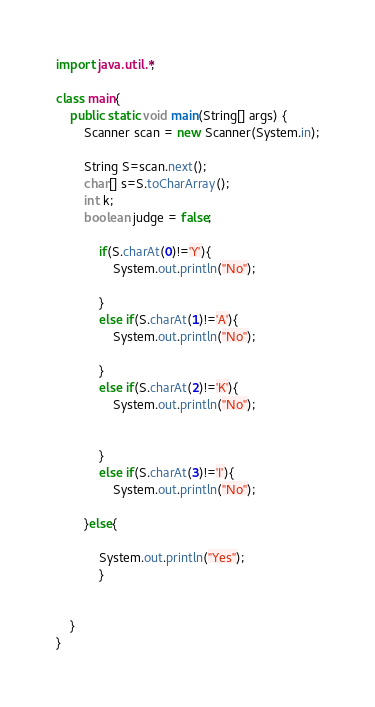<code> <loc_0><loc_0><loc_500><loc_500><_Java_>import java.util.*;

class main{
    public static void main(String[] args) {
        Scanner scan = new Scanner(System.in);

        String S=scan.next();
        char[] s=S.toCharArray();
        int k;
        boolean judge = false;

            if(S.charAt(0)!='Y'){
                System.out.println("No");
		
            }
            else if(S.charAt(1)!='A'){
                System.out.println("No");
		
            }
            else if(S.charAt(2)!='K'){
                System.out.println("No");

		
            }
            else if(S.charAt(3)!='I'){
                System.out.println("No");
		
	    }else{
        	
            System.out.println("Yes");
            }


    }
}
</code> 